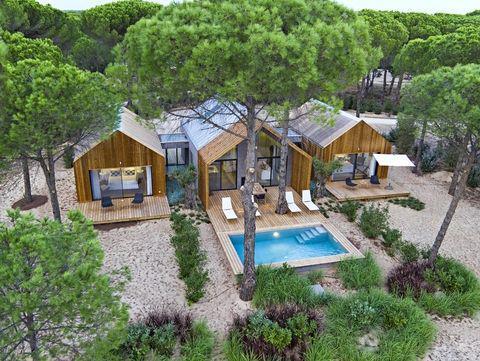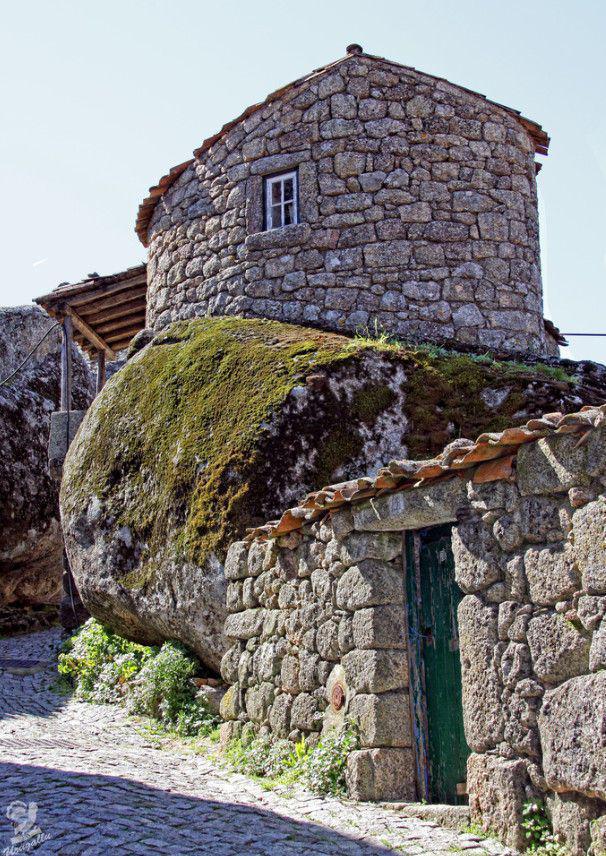The first image is the image on the left, the second image is the image on the right. Evaluate the accuracy of this statement regarding the images: "There are chairs outside.". Is it true? Answer yes or no. Yes. The first image is the image on the left, the second image is the image on the right. Examine the images to the left and right. Is the description "The right image includes rustic curving walls made of stones of varying shapes." accurate? Answer yes or no. Yes. 